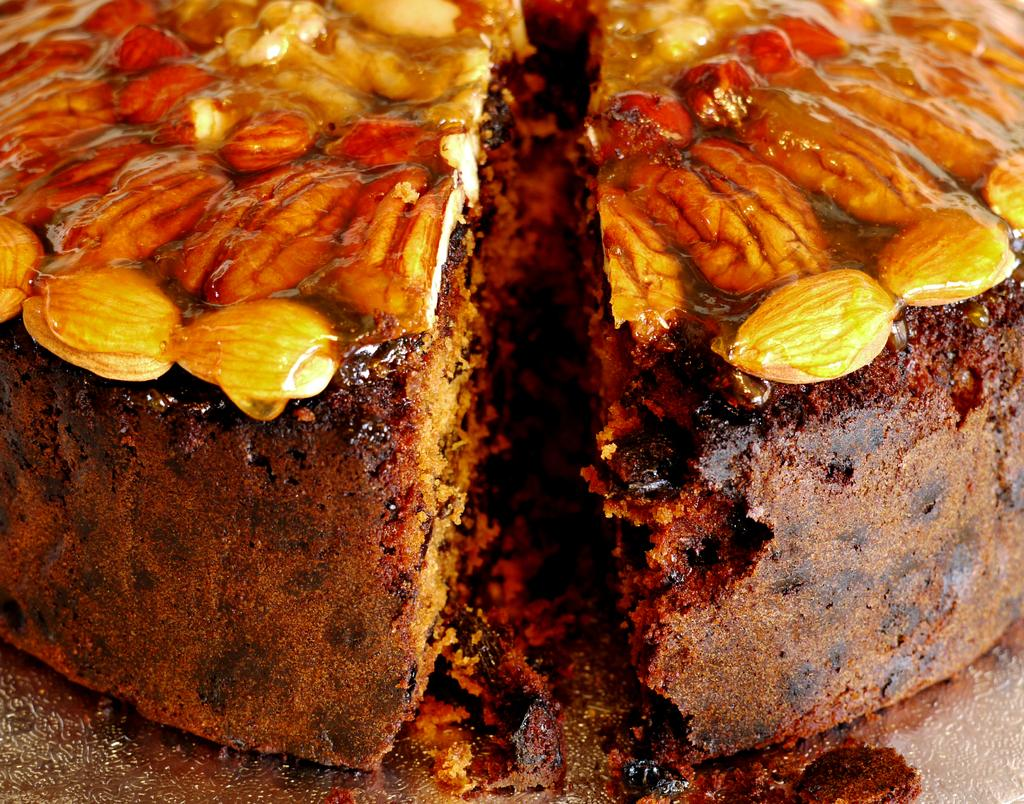What type of cake is visible in the image? There is a brown color cake in the image. What decorations can be seen on the cake? There are dry fruits on the cake. What type of chalk is used to draw on the cake? There is no chalk present on the cake in the image. How many legs can be seen on the cake? The cake does not have legs; it is a stationary object in the image. Are there any horses depicted on the cake? There are no horses depicted on the cake in the image. 